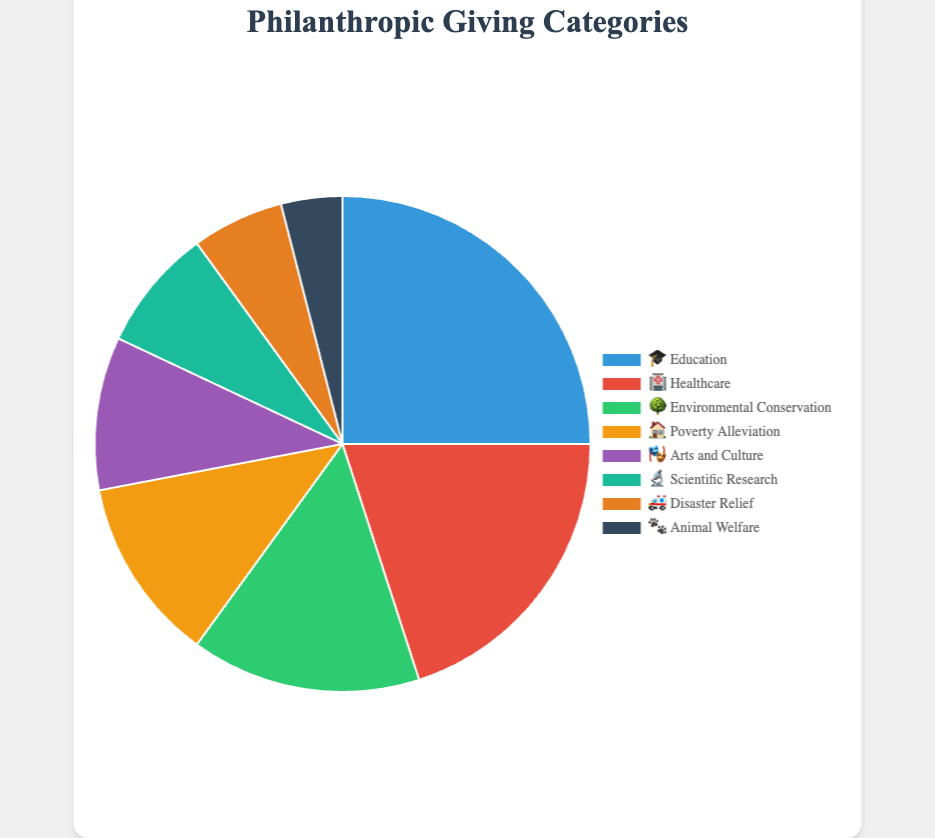Which category has the highest percentage of philanthropic giving? The highest percentage category can be identified by looking at the data with the largest segment in the pie chart. The segment labeled '🎓 Education' has the highest percentage.
Answer: Education What is the total percentage of philanthropic giving represented by 'Arts and Culture' and 'Scientific Research'? Add the percentages of '🎭 Arts and Culture' (10%) and '🔬 Scientific Research' (8%). This equals 10 + 8 = 18%.
Answer: 18% Which category has a smaller percentage of philanthropic giving than 'Disaster Relief'? Find the segment with the label '🚑 Disaster Relief' which has 6% and then find any segment with a smaller percentage. Only '🐾 Animal Welfare', at 4%, fits this criterion.
Answer: Animal Welfare How many categories have a percentage greater than 10%? Identify and count the segments with percentages greater than 10%. These are '🎓 Education' (25%), '🏥 Healthcare' (20%), '🌳 Environmental Conservation' (15%), and '🏠 Poverty Alleviation' (12%). There are 4 such categories.
Answer: 4 Among Education, Healthcare, and Environmental Conservation, which has the smallest proportion of philanthropic support? Compare the percentages of '🎓 Education' (25%), '🏥 Healthcare' (20%), and '🌳 Environmental Conservation' (15%). The smallest percentage is for '🌳 Environmental Conservation'.
Answer: Environmental Conservation How does the philanthropic percentage for Healthcare compare with Arts and Culture combined with Animal Welfare? Calculate the combined percentage of '🎭 Arts and Culture' (10%) and '🐾 Animal Welfare' (4%) which is 10 + 4 = 14%, and compare it with '🏥 Healthcare' (20%). Healthcare has a higher percentage than the combined total of Arts and Culture with Animal Welfare.
Answer: Higher What is the combined percentage of categories with the lowest 3 philanthropic contributions? Add the percentages of '🔬 Scientific Research' (8%), '🚑 Disaster Relief' (6%), and '🐾 Animal Welfare' (4%). This equals 8 + 6 + 4 = 18%.
Answer: 18% Which category's contribution is closest to the median value of all categories' contributions? First, list all percentages: 25, 20, 15, 12, 10, 8, 6, 4. The median value is the average of the 4th and 5th values in the sorted list: (12 + 10) / 2 = 11%. The closest category is '🏠 Poverty Alleviation' at 12%.
Answer: Poverty Alleviation 